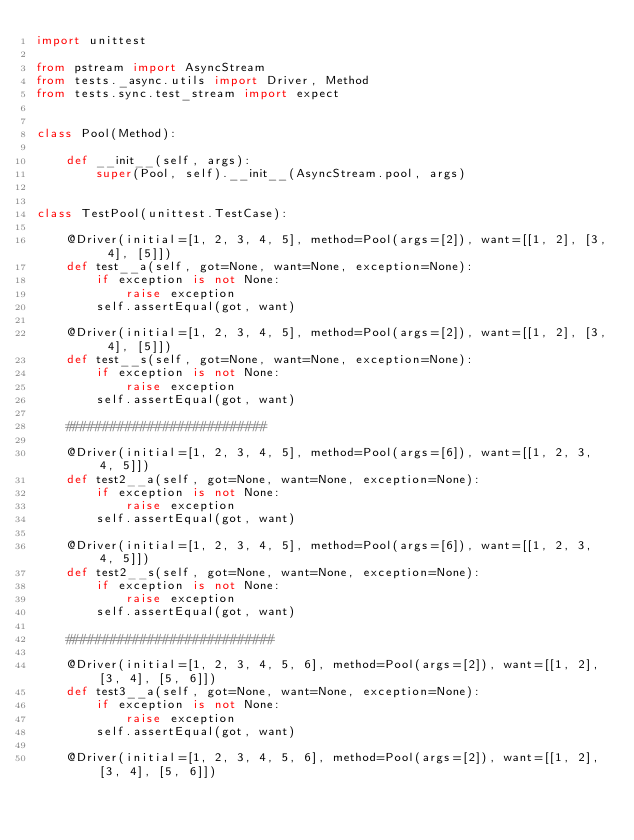<code> <loc_0><loc_0><loc_500><loc_500><_Python_>import unittest

from pstream import AsyncStream
from tests._async.utils import Driver, Method
from tests.sync.test_stream import expect


class Pool(Method):

    def __init__(self, args):
        super(Pool, self).__init__(AsyncStream.pool, args)


class TestPool(unittest.TestCase):

    @Driver(initial=[1, 2, 3, 4, 5], method=Pool(args=[2]), want=[[1, 2], [3, 4], [5]])
    def test__a(self, got=None, want=None, exception=None):
        if exception is not None:
            raise exception
        self.assertEqual(got, want)

    @Driver(initial=[1, 2, 3, 4, 5], method=Pool(args=[2]), want=[[1, 2], [3, 4], [5]])
    def test__s(self, got=None, want=None, exception=None):
        if exception is not None:
            raise exception
        self.assertEqual(got, want)

    ###########################

    @Driver(initial=[1, 2, 3, 4, 5], method=Pool(args=[6]), want=[[1, 2, 3, 4, 5]])
    def test2__a(self, got=None, want=None, exception=None):
        if exception is not None:
            raise exception
        self.assertEqual(got, want)

    @Driver(initial=[1, 2, 3, 4, 5], method=Pool(args=[6]), want=[[1, 2, 3, 4, 5]])
    def test2__s(self, got=None, want=None, exception=None):
        if exception is not None:
            raise exception
        self.assertEqual(got, want)

    ############################

    @Driver(initial=[1, 2, 3, 4, 5, 6], method=Pool(args=[2]), want=[[1, 2], [3, 4], [5, 6]])
    def test3__a(self, got=None, want=None, exception=None):
        if exception is not None:
            raise exception
        self.assertEqual(got, want)

    @Driver(initial=[1, 2, 3, 4, 5, 6], method=Pool(args=[2]), want=[[1, 2], [3, 4], [5, 6]])</code> 